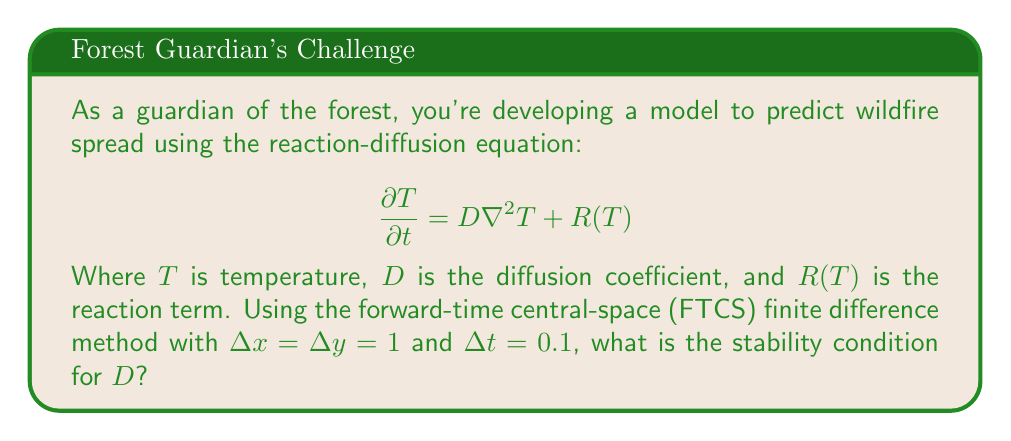Could you help me with this problem? To determine the stability condition for the FTCS method applied to the 2D reaction-diffusion equation, we follow these steps:

1) The FTCS scheme for the 2D reaction-diffusion equation is:

   $$T_{i,j}^{n+1} = T_{i,j}^n + \frac{D\Delta t}{(\Delta x)^2}(T_{i+1,j}^n + T_{i-1,j}^n + T_{i,j+1}^n + T_{i,j-1}^n - 4T_{i,j}^n) + \Delta t R(T_{i,j}^n)$$

2) For stability analysis, we focus on the diffusion term and ignore the reaction term.

3) The von Neumann stability analysis requires that the amplification factor $|G| \leq 1$.

4) Substituting a Fourier mode $T_{i,j}^n = G^n e^{I(k_x i\Delta x + k_y j\Delta y)}$ into the scheme:

   $$G = 1 + \frac{4D\Delta t}{(\Delta x)^2}(\cos(k_x\Delta x) + \cos(k_y\Delta y) - 2)$$

5) The most restrictive case is when $\cos(k_x\Delta x) + \cos(k_y\Delta y) = -2$, giving:

   $$G = 1 - \frac{16D\Delta t}{(\Delta x)^2}$$

6) For stability, we require $|G| \leq 1$, which means:

   $$-1 \leq 1 - \frac{16D\Delta t}{(\Delta x)^2} \leq 1$$

7) The right inequality is always satisfied. From the left inequality:

   $$\frac{16D\Delta t}{(\Delta x)^2} \leq 2$$

8) Substituting the given values $\Delta x = 1$ and $\Delta t = 0.1$:

   $$\frac{16D(0.1)}{1^2} \leq 2$$

9) Solving for $D$:

   $$D \leq \frac{2}{1.6} = 1.25$$

Therefore, the stability condition for $D$ is $D \leq 1.25$.
Answer: $D \leq 1.25$ 